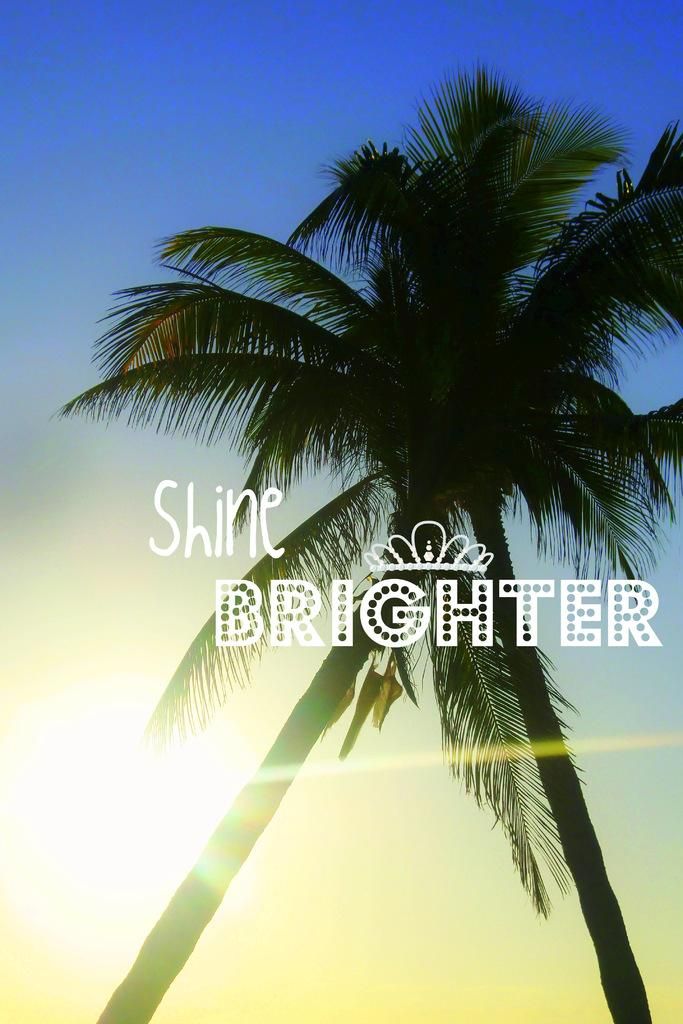How many coconut trees are in the image? There are two coconut trees in the image. What can be seen in the background of the image? There is sky visible in the background of the image. Is there any text present in the image? Yes, there is text written on the image. Can you see a gun in the image? No, there is no gun present in the image. 